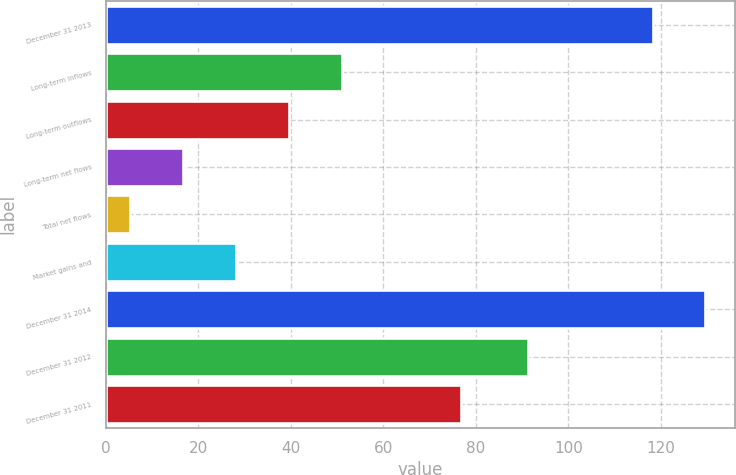<chart> <loc_0><loc_0><loc_500><loc_500><bar_chart><fcel>December 31 2013<fcel>Long-term inflows<fcel>Long-term outflows<fcel>Long-term net flows<fcel>Total net flows<fcel>Market gains and<fcel>December 31 2014<fcel>December 31 2012<fcel>December 31 2011<nl><fcel>118.2<fcel>51<fcel>39.55<fcel>16.65<fcel>5.2<fcel>28.1<fcel>129.65<fcel>91.2<fcel>76.9<nl></chart> 